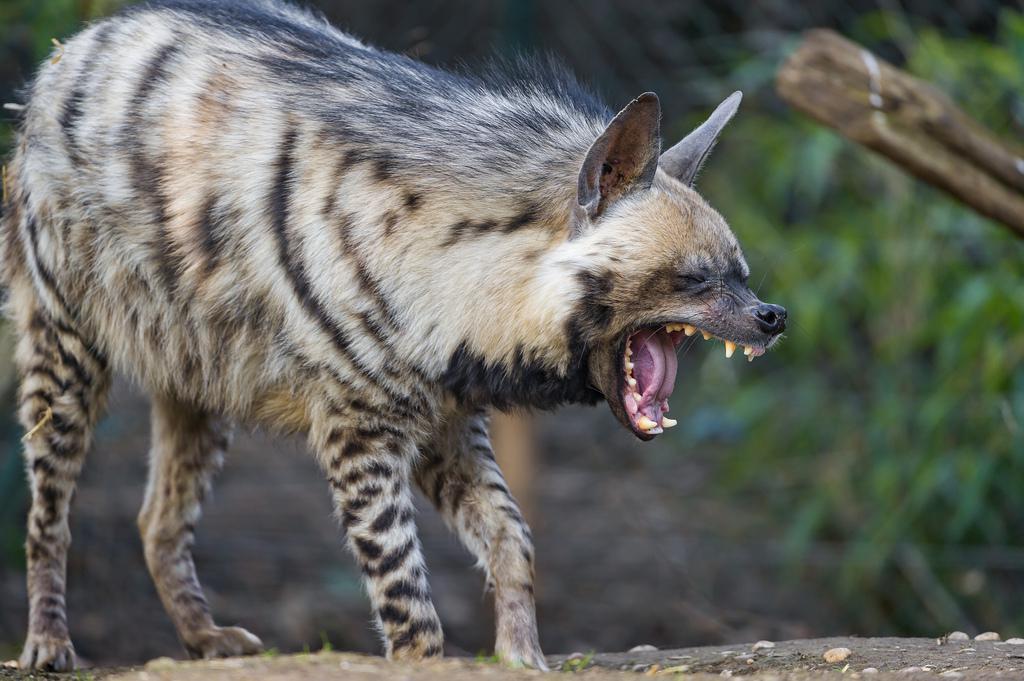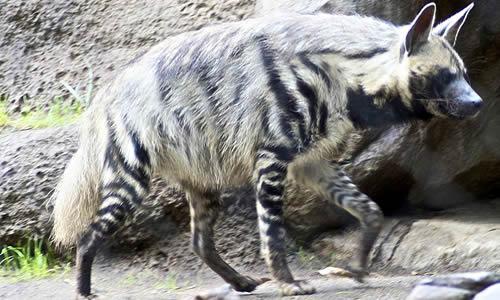The first image is the image on the left, the second image is the image on the right. Analyze the images presented: Is the assertion "There is at most two hyenas." valid? Answer yes or no. Yes. The first image is the image on the left, the second image is the image on the right. Considering the images on both sides, is "Each picture has exactly one hyena." valid? Answer yes or no. Yes. 